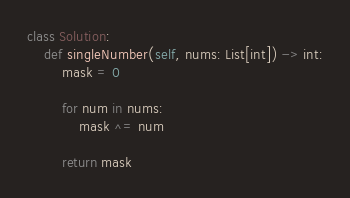<code> <loc_0><loc_0><loc_500><loc_500><_Python_>class Solution:
    def singleNumber(self, nums: List[int]) -> int:
        mask = 0

        for num in nums:
            mask ^= num

        return mask

</code> 